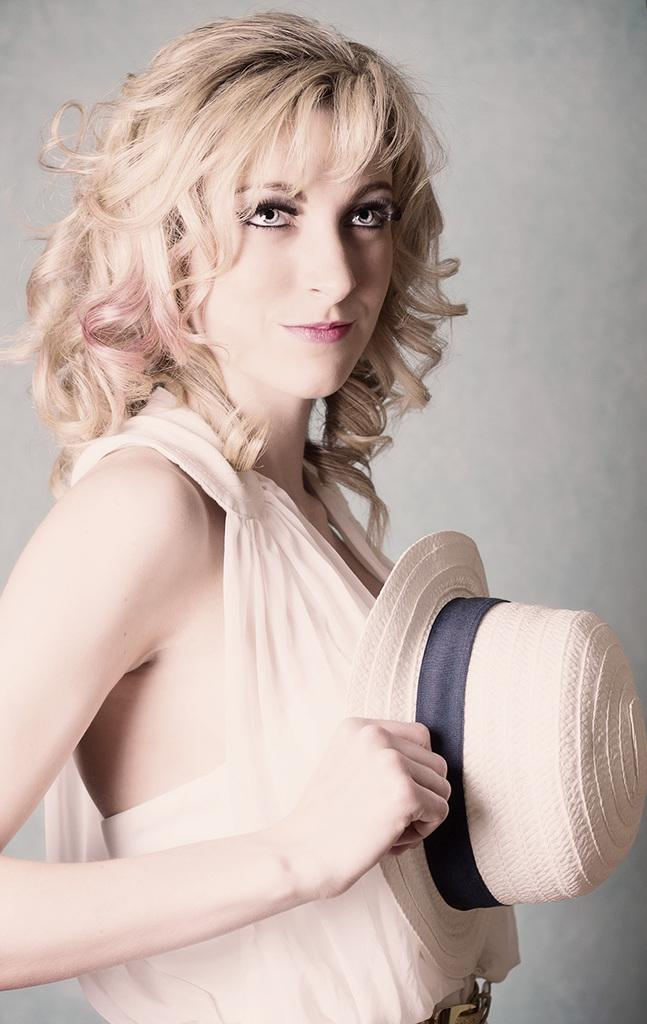What is the main subject of the image? There is a person standing in the image. What is the person wearing? The person is wearing a cream-colored dress. What is the person holding in the image? The person is holding a cap. What is the color of the cap? The cap is also in cream color. What can be seen in the background of the image? The background of the image is white. How many clocks can be seen in the image? There are no clocks visible in the image. Are there any children present in the image? There is no mention of children in the provided facts, and therefore no children can be seen in the image. 